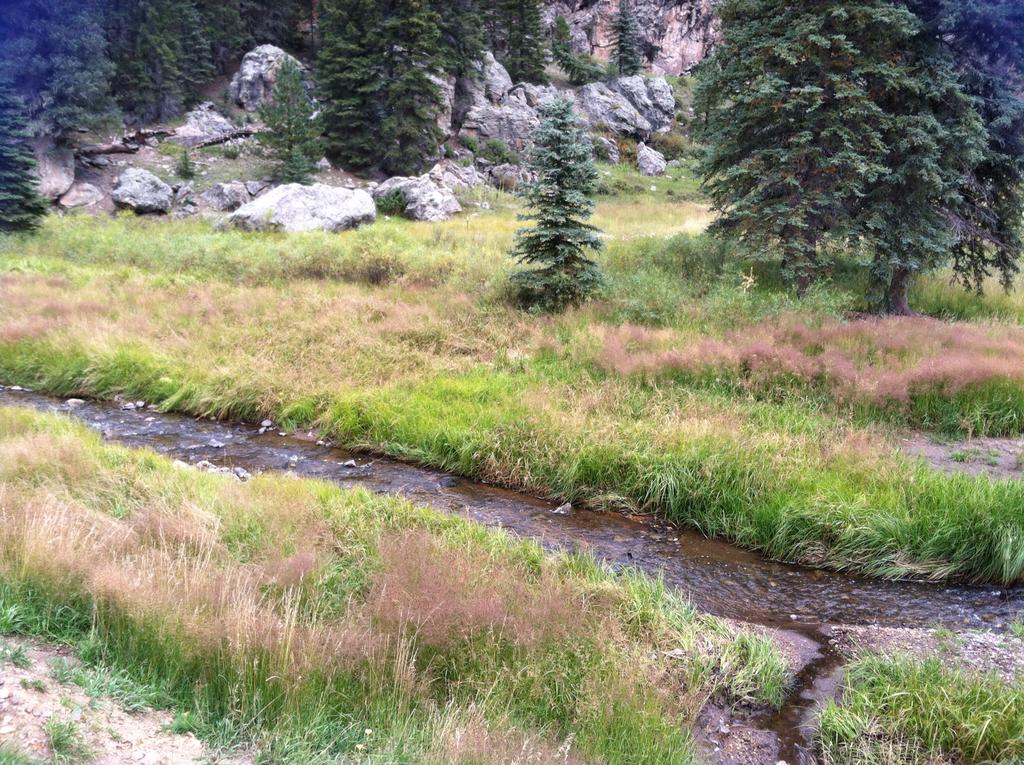What type of terrain is depicted in the image? There is a grass field in the image. Is there any water visible in the image? Yes, there is a small water flow in the middle of the grass field. What other natural elements can be seen in the image? There are trees and rocks in the image. Where is the patch of yams located in the image? There is no patch of yams present in the image. What type of doll can be seen playing near the trees in the image? There is no doll present in the image. 